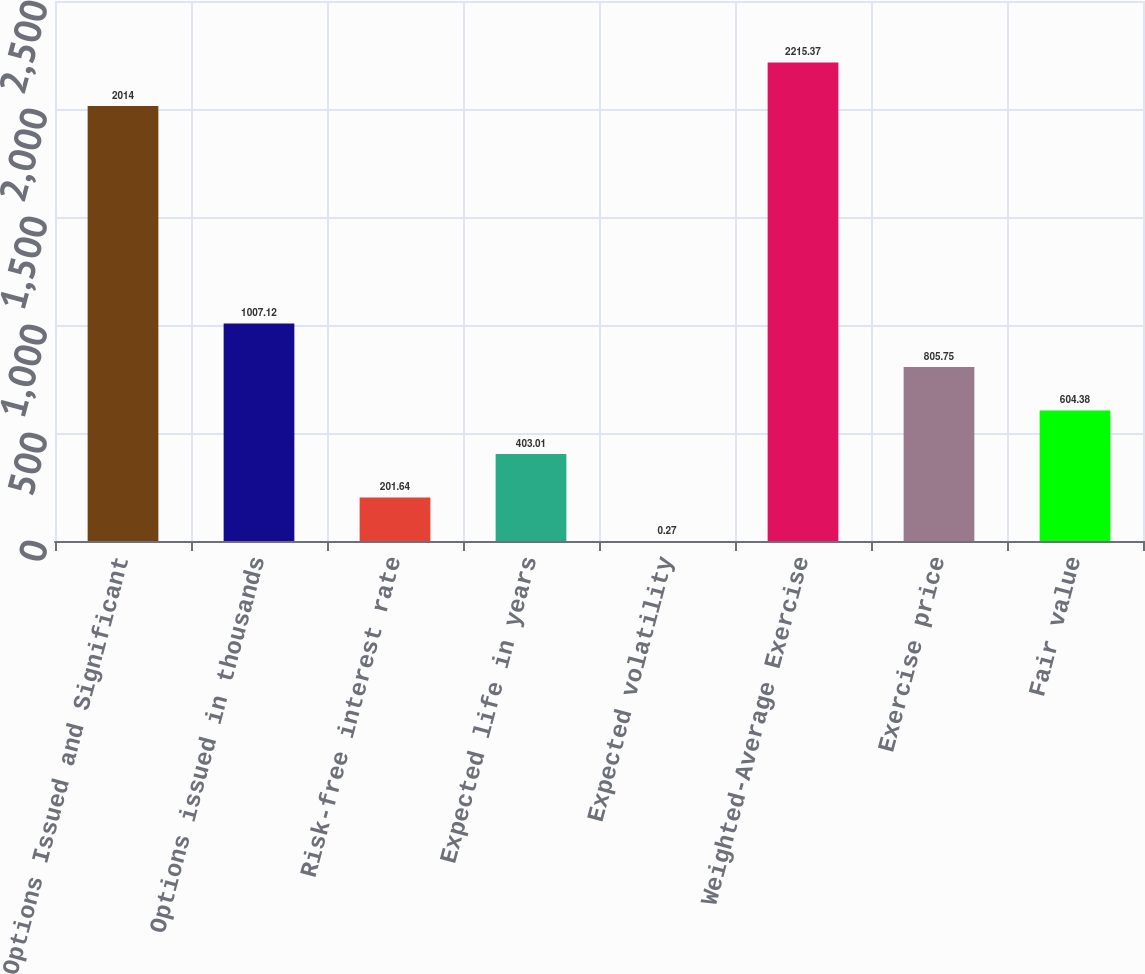Convert chart. <chart><loc_0><loc_0><loc_500><loc_500><bar_chart><fcel>Options Issued and Significant<fcel>Options issued in thousands<fcel>Risk-free interest rate<fcel>Expected life in years<fcel>Expected volatility<fcel>Weighted-Average Exercise<fcel>Exercise price<fcel>Fair value<nl><fcel>2014<fcel>1007.12<fcel>201.64<fcel>403.01<fcel>0.27<fcel>2215.37<fcel>805.75<fcel>604.38<nl></chart> 